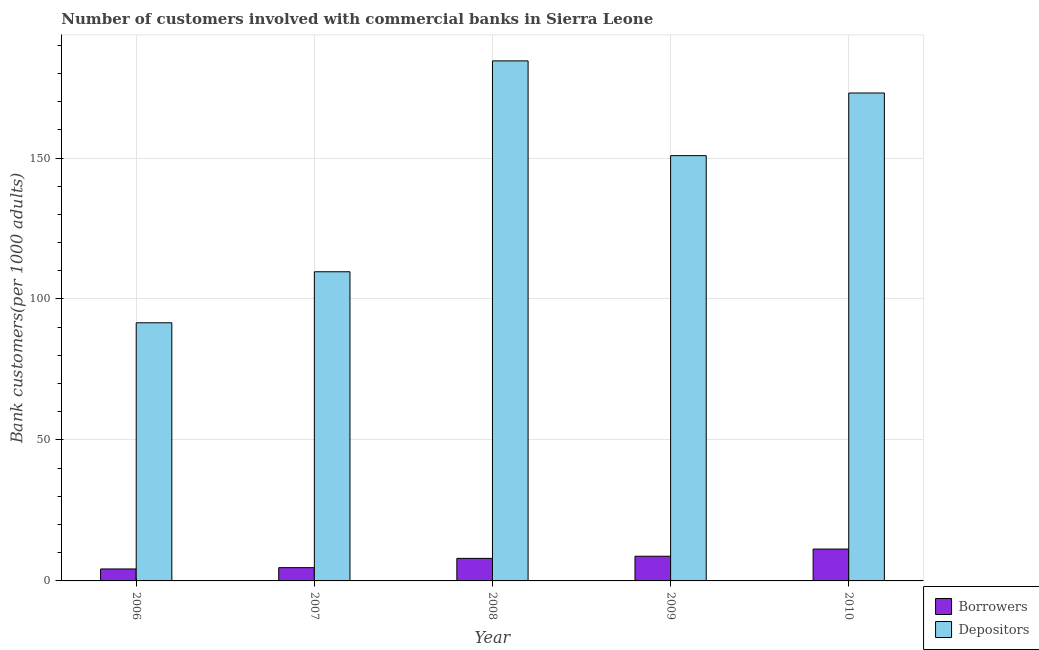Are the number of bars on each tick of the X-axis equal?
Your answer should be compact. Yes. How many bars are there on the 2nd tick from the right?
Keep it short and to the point. 2. What is the number of borrowers in 2008?
Your answer should be compact. 7.99. Across all years, what is the maximum number of depositors?
Offer a terse response. 184.46. Across all years, what is the minimum number of depositors?
Your answer should be compact. 91.57. What is the total number of depositors in the graph?
Your answer should be very brief. 709.61. What is the difference between the number of depositors in 2008 and that in 2009?
Offer a terse response. 33.62. What is the difference between the number of borrowers in 2009 and the number of depositors in 2008?
Ensure brevity in your answer.  0.76. What is the average number of depositors per year?
Make the answer very short. 141.92. In the year 2010, what is the difference between the number of depositors and number of borrowers?
Provide a short and direct response. 0. In how many years, is the number of depositors greater than 150?
Your response must be concise. 3. What is the ratio of the number of borrowers in 2008 to that in 2010?
Provide a succinct answer. 0.71. Is the difference between the number of depositors in 2006 and 2009 greater than the difference between the number of borrowers in 2006 and 2009?
Provide a short and direct response. No. What is the difference between the highest and the second highest number of depositors?
Offer a very short reply. 11.39. What is the difference between the highest and the lowest number of depositors?
Keep it short and to the point. 92.89. What does the 1st bar from the left in 2010 represents?
Make the answer very short. Borrowers. What does the 2nd bar from the right in 2006 represents?
Provide a short and direct response. Borrowers. How many bars are there?
Provide a succinct answer. 10. Are all the bars in the graph horizontal?
Make the answer very short. No. How many years are there in the graph?
Offer a very short reply. 5. Where does the legend appear in the graph?
Give a very brief answer. Bottom right. What is the title of the graph?
Provide a succinct answer. Number of customers involved with commercial banks in Sierra Leone. Does "Register a property" appear as one of the legend labels in the graph?
Provide a succinct answer. No. What is the label or title of the X-axis?
Provide a short and direct response. Year. What is the label or title of the Y-axis?
Give a very brief answer. Bank customers(per 1000 adults). What is the Bank customers(per 1000 adults) in Borrowers in 2006?
Offer a terse response. 4.24. What is the Bank customers(per 1000 adults) of Depositors in 2006?
Ensure brevity in your answer.  91.57. What is the Bank customers(per 1000 adults) in Borrowers in 2007?
Your answer should be compact. 4.71. What is the Bank customers(per 1000 adults) of Depositors in 2007?
Your answer should be very brief. 109.66. What is the Bank customers(per 1000 adults) of Borrowers in 2008?
Your response must be concise. 7.99. What is the Bank customers(per 1000 adults) of Depositors in 2008?
Offer a very short reply. 184.46. What is the Bank customers(per 1000 adults) of Borrowers in 2009?
Ensure brevity in your answer.  8.75. What is the Bank customers(per 1000 adults) of Depositors in 2009?
Offer a very short reply. 150.85. What is the Bank customers(per 1000 adults) of Borrowers in 2010?
Keep it short and to the point. 11.3. What is the Bank customers(per 1000 adults) in Depositors in 2010?
Provide a succinct answer. 173.07. Across all years, what is the maximum Bank customers(per 1000 adults) of Borrowers?
Provide a short and direct response. 11.3. Across all years, what is the maximum Bank customers(per 1000 adults) in Depositors?
Make the answer very short. 184.46. Across all years, what is the minimum Bank customers(per 1000 adults) of Borrowers?
Offer a terse response. 4.24. Across all years, what is the minimum Bank customers(per 1000 adults) in Depositors?
Ensure brevity in your answer.  91.57. What is the total Bank customers(per 1000 adults) in Borrowers in the graph?
Offer a terse response. 36.99. What is the total Bank customers(per 1000 adults) in Depositors in the graph?
Make the answer very short. 709.61. What is the difference between the Bank customers(per 1000 adults) in Borrowers in 2006 and that in 2007?
Your answer should be very brief. -0.47. What is the difference between the Bank customers(per 1000 adults) in Depositors in 2006 and that in 2007?
Make the answer very short. -18.09. What is the difference between the Bank customers(per 1000 adults) in Borrowers in 2006 and that in 2008?
Make the answer very short. -3.75. What is the difference between the Bank customers(per 1000 adults) of Depositors in 2006 and that in 2008?
Give a very brief answer. -92.89. What is the difference between the Bank customers(per 1000 adults) of Borrowers in 2006 and that in 2009?
Offer a very short reply. -4.51. What is the difference between the Bank customers(per 1000 adults) in Depositors in 2006 and that in 2009?
Your response must be concise. -59.28. What is the difference between the Bank customers(per 1000 adults) in Borrowers in 2006 and that in 2010?
Give a very brief answer. -7.06. What is the difference between the Bank customers(per 1000 adults) of Depositors in 2006 and that in 2010?
Your answer should be compact. -81.5. What is the difference between the Bank customers(per 1000 adults) in Borrowers in 2007 and that in 2008?
Offer a very short reply. -3.29. What is the difference between the Bank customers(per 1000 adults) of Depositors in 2007 and that in 2008?
Ensure brevity in your answer.  -74.8. What is the difference between the Bank customers(per 1000 adults) in Borrowers in 2007 and that in 2009?
Your answer should be compact. -4.05. What is the difference between the Bank customers(per 1000 adults) in Depositors in 2007 and that in 2009?
Ensure brevity in your answer.  -41.18. What is the difference between the Bank customers(per 1000 adults) in Borrowers in 2007 and that in 2010?
Provide a succinct answer. -6.59. What is the difference between the Bank customers(per 1000 adults) in Depositors in 2007 and that in 2010?
Make the answer very short. -63.41. What is the difference between the Bank customers(per 1000 adults) of Borrowers in 2008 and that in 2009?
Make the answer very short. -0.76. What is the difference between the Bank customers(per 1000 adults) of Depositors in 2008 and that in 2009?
Keep it short and to the point. 33.62. What is the difference between the Bank customers(per 1000 adults) in Borrowers in 2008 and that in 2010?
Provide a short and direct response. -3.3. What is the difference between the Bank customers(per 1000 adults) in Depositors in 2008 and that in 2010?
Make the answer very short. 11.39. What is the difference between the Bank customers(per 1000 adults) of Borrowers in 2009 and that in 2010?
Make the answer very short. -2.54. What is the difference between the Bank customers(per 1000 adults) in Depositors in 2009 and that in 2010?
Ensure brevity in your answer.  -22.22. What is the difference between the Bank customers(per 1000 adults) in Borrowers in 2006 and the Bank customers(per 1000 adults) in Depositors in 2007?
Provide a succinct answer. -105.42. What is the difference between the Bank customers(per 1000 adults) of Borrowers in 2006 and the Bank customers(per 1000 adults) of Depositors in 2008?
Provide a succinct answer. -180.22. What is the difference between the Bank customers(per 1000 adults) of Borrowers in 2006 and the Bank customers(per 1000 adults) of Depositors in 2009?
Your answer should be very brief. -146.61. What is the difference between the Bank customers(per 1000 adults) in Borrowers in 2006 and the Bank customers(per 1000 adults) in Depositors in 2010?
Offer a terse response. -168.83. What is the difference between the Bank customers(per 1000 adults) in Borrowers in 2007 and the Bank customers(per 1000 adults) in Depositors in 2008?
Ensure brevity in your answer.  -179.76. What is the difference between the Bank customers(per 1000 adults) of Borrowers in 2007 and the Bank customers(per 1000 adults) of Depositors in 2009?
Provide a short and direct response. -146.14. What is the difference between the Bank customers(per 1000 adults) of Borrowers in 2007 and the Bank customers(per 1000 adults) of Depositors in 2010?
Provide a short and direct response. -168.36. What is the difference between the Bank customers(per 1000 adults) in Borrowers in 2008 and the Bank customers(per 1000 adults) in Depositors in 2009?
Offer a very short reply. -142.85. What is the difference between the Bank customers(per 1000 adults) in Borrowers in 2008 and the Bank customers(per 1000 adults) in Depositors in 2010?
Ensure brevity in your answer.  -165.08. What is the difference between the Bank customers(per 1000 adults) in Borrowers in 2009 and the Bank customers(per 1000 adults) in Depositors in 2010?
Provide a short and direct response. -164.32. What is the average Bank customers(per 1000 adults) of Borrowers per year?
Your response must be concise. 7.4. What is the average Bank customers(per 1000 adults) of Depositors per year?
Provide a succinct answer. 141.92. In the year 2006, what is the difference between the Bank customers(per 1000 adults) of Borrowers and Bank customers(per 1000 adults) of Depositors?
Your answer should be very brief. -87.33. In the year 2007, what is the difference between the Bank customers(per 1000 adults) of Borrowers and Bank customers(per 1000 adults) of Depositors?
Your answer should be very brief. -104.96. In the year 2008, what is the difference between the Bank customers(per 1000 adults) in Borrowers and Bank customers(per 1000 adults) in Depositors?
Offer a very short reply. -176.47. In the year 2009, what is the difference between the Bank customers(per 1000 adults) of Borrowers and Bank customers(per 1000 adults) of Depositors?
Your response must be concise. -142.09. In the year 2010, what is the difference between the Bank customers(per 1000 adults) in Borrowers and Bank customers(per 1000 adults) in Depositors?
Offer a terse response. -161.77. What is the ratio of the Bank customers(per 1000 adults) in Borrowers in 2006 to that in 2007?
Make the answer very short. 0.9. What is the ratio of the Bank customers(per 1000 adults) in Depositors in 2006 to that in 2007?
Provide a succinct answer. 0.83. What is the ratio of the Bank customers(per 1000 adults) in Borrowers in 2006 to that in 2008?
Give a very brief answer. 0.53. What is the ratio of the Bank customers(per 1000 adults) of Depositors in 2006 to that in 2008?
Keep it short and to the point. 0.5. What is the ratio of the Bank customers(per 1000 adults) of Borrowers in 2006 to that in 2009?
Give a very brief answer. 0.48. What is the ratio of the Bank customers(per 1000 adults) in Depositors in 2006 to that in 2009?
Offer a very short reply. 0.61. What is the ratio of the Bank customers(per 1000 adults) of Borrowers in 2006 to that in 2010?
Your answer should be compact. 0.38. What is the ratio of the Bank customers(per 1000 adults) of Depositors in 2006 to that in 2010?
Your response must be concise. 0.53. What is the ratio of the Bank customers(per 1000 adults) in Borrowers in 2007 to that in 2008?
Your answer should be very brief. 0.59. What is the ratio of the Bank customers(per 1000 adults) in Depositors in 2007 to that in 2008?
Offer a very short reply. 0.59. What is the ratio of the Bank customers(per 1000 adults) in Borrowers in 2007 to that in 2009?
Your response must be concise. 0.54. What is the ratio of the Bank customers(per 1000 adults) in Depositors in 2007 to that in 2009?
Provide a short and direct response. 0.73. What is the ratio of the Bank customers(per 1000 adults) of Borrowers in 2007 to that in 2010?
Provide a short and direct response. 0.42. What is the ratio of the Bank customers(per 1000 adults) of Depositors in 2007 to that in 2010?
Offer a very short reply. 0.63. What is the ratio of the Bank customers(per 1000 adults) of Borrowers in 2008 to that in 2009?
Make the answer very short. 0.91. What is the ratio of the Bank customers(per 1000 adults) in Depositors in 2008 to that in 2009?
Make the answer very short. 1.22. What is the ratio of the Bank customers(per 1000 adults) in Borrowers in 2008 to that in 2010?
Your response must be concise. 0.71. What is the ratio of the Bank customers(per 1000 adults) in Depositors in 2008 to that in 2010?
Your answer should be compact. 1.07. What is the ratio of the Bank customers(per 1000 adults) of Borrowers in 2009 to that in 2010?
Offer a very short reply. 0.77. What is the ratio of the Bank customers(per 1000 adults) in Depositors in 2009 to that in 2010?
Ensure brevity in your answer.  0.87. What is the difference between the highest and the second highest Bank customers(per 1000 adults) in Borrowers?
Ensure brevity in your answer.  2.54. What is the difference between the highest and the second highest Bank customers(per 1000 adults) of Depositors?
Your response must be concise. 11.39. What is the difference between the highest and the lowest Bank customers(per 1000 adults) of Borrowers?
Provide a short and direct response. 7.06. What is the difference between the highest and the lowest Bank customers(per 1000 adults) in Depositors?
Provide a succinct answer. 92.89. 